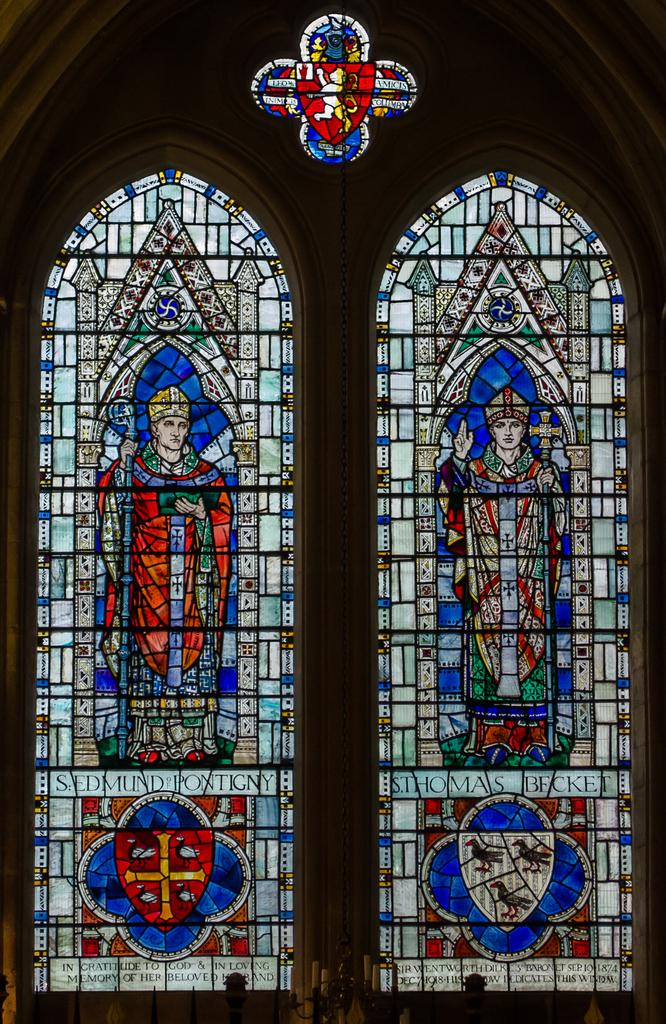What can be seen on the windows in the image? There is a design on the glass of the windows. What feature of the windows allows us to see the design? The windows have glass that allows the design to be visible. What else can be seen in the image besides the windows? There are objects visible in the image. What type of cough can be heard coming from the window in the image? There is no sound, including coughing, present in the image. What type of leaf is visible on the window in the image? There are no leaves present in the image. 